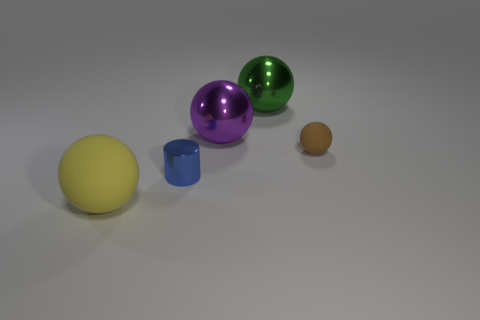Subtract all large yellow matte balls. How many balls are left? 3 Add 2 spheres. How many objects exist? 7 Subtract all green balls. How many balls are left? 3 Subtract all cylinders. How many objects are left? 4 Subtract all cyan cylinders. Subtract all purple spheres. How many cylinders are left? 1 Subtract all big gray rubber blocks. Subtract all big shiny spheres. How many objects are left? 3 Add 4 spheres. How many spheres are left? 8 Add 1 big rubber things. How many big rubber things exist? 2 Subtract 0 green cylinders. How many objects are left? 5 